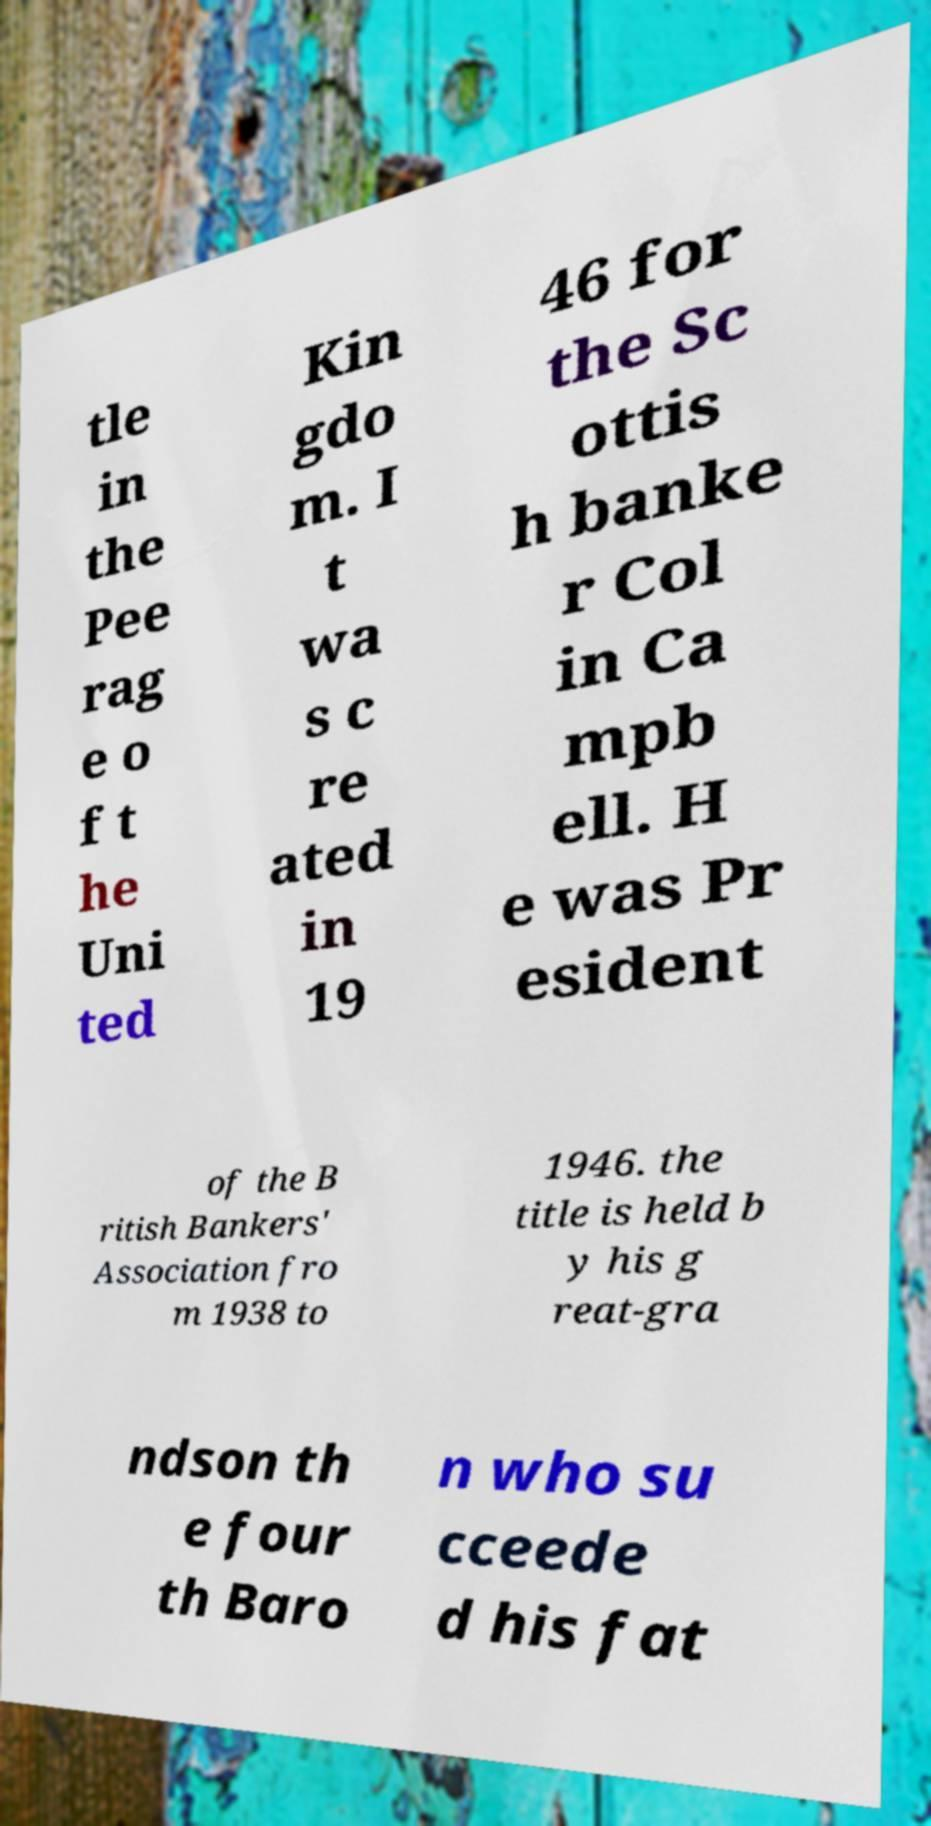Could you assist in decoding the text presented in this image and type it out clearly? tle in the Pee rag e o f t he Uni ted Kin gdo m. I t wa s c re ated in 19 46 for the Sc ottis h banke r Col in Ca mpb ell. H e was Pr esident of the B ritish Bankers' Association fro m 1938 to 1946. the title is held b y his g reat-gra ndson th e four th Baro n who su cceede d his fat 